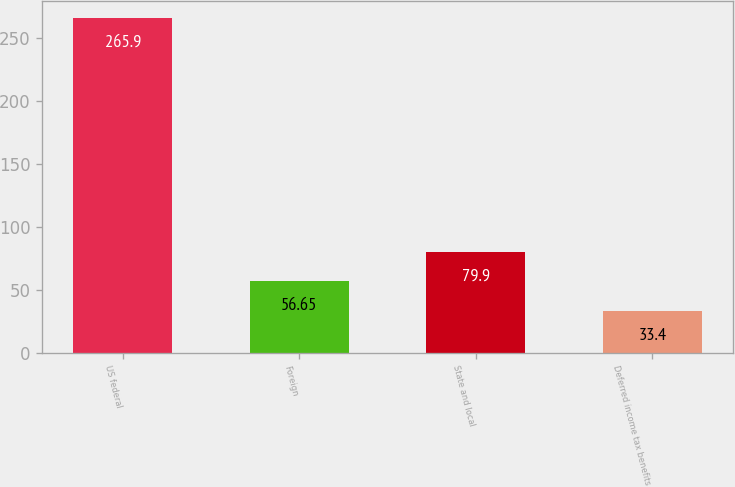<chart> <loc_0><loc_0><loc_500><loc_500><bar_chart><fcel>US federal<fcel>Foreign<fcel>State and local<fcel>Deferred income tax benefits<nl><fcel>265.9<fcel>56.65<fcel>79.9<fcel>33.4<nl></chart> 